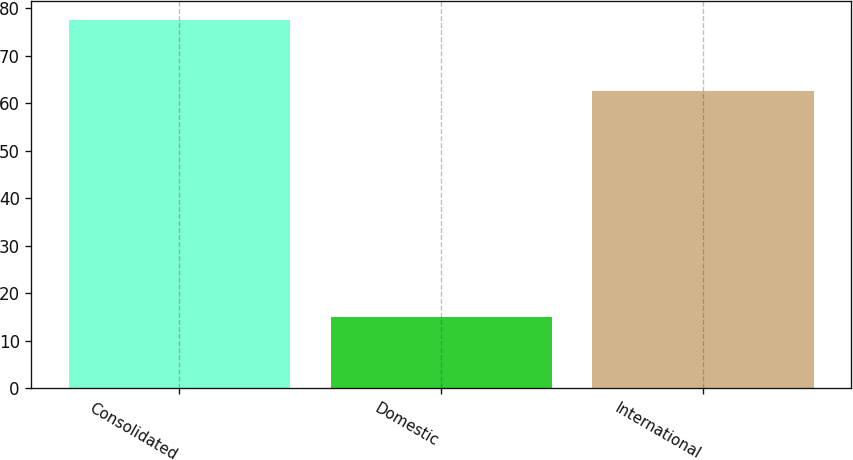Convert chart. <chart><loc_0><loc_0><loc_500><loc_500><bar_chart><fcel>Consolidated<fcel>Domestic<fcel>International<nl><fcel>77.6<fcel>15<fcel>62.6<nl></chart> 